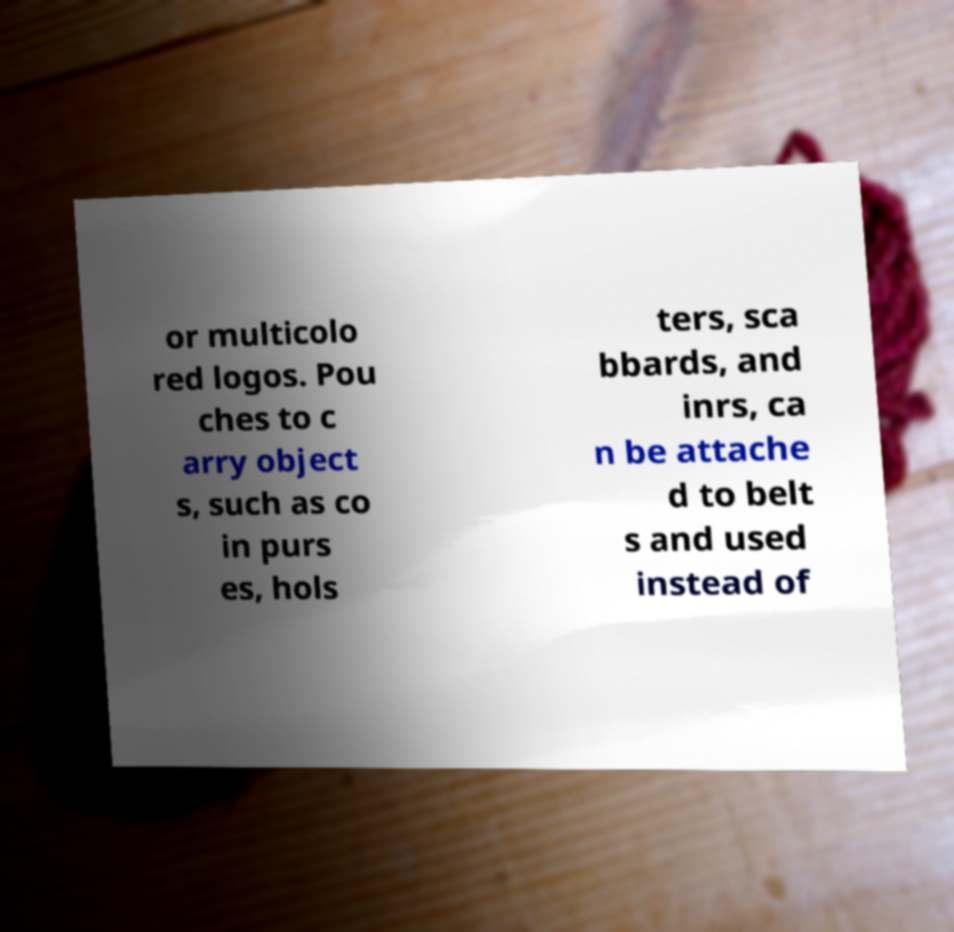Could you assist in decoding the text presented in this image and type it out clearly? or multicolo red logos. Pou ches to c arry object s, such as co in purs es, hols ters, sca bbards, and inrs, ca n be attache d to belt s and used instead of 